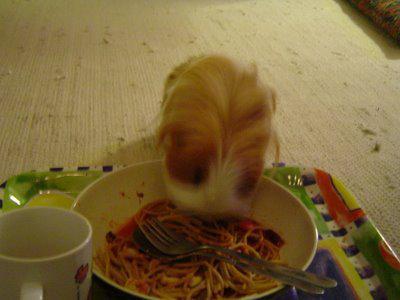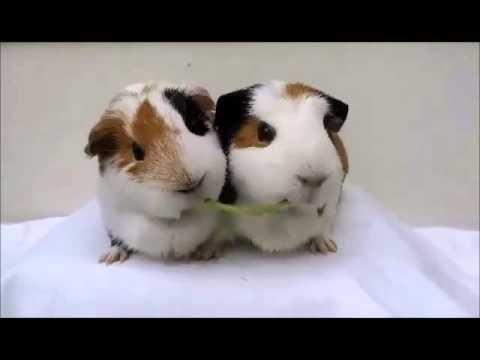The first image is the image on the left, the second image is the image on the right. For the images shown, is this caption "The rodent in the image on the left sits on a surface to eat noodles." true? Answer yes or no. Yes. The first image is the image on the left, the second image is the image on the right. Examine the images to the left and right. Is the description "A rodent is eating pasta in the left image." accurate? Answer yes or no. Yes. 